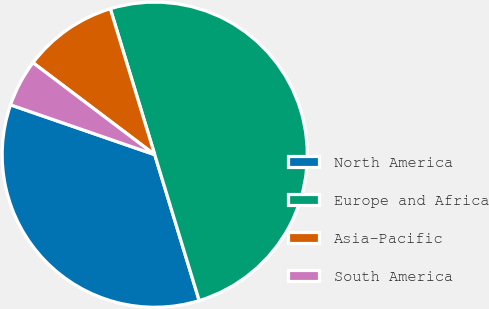Convert chart to OTSL. <chart><loc_0><loc_0><loc_500><loc_500><pie_chart><fcel>North America<fcel>Europe and Africa<fcel>Asia-Pacific<fcel>South America<nl><fcel>35.0%<fcel>50.0%<fcel>10.0%<fcel>5.0%<nl></chart> 